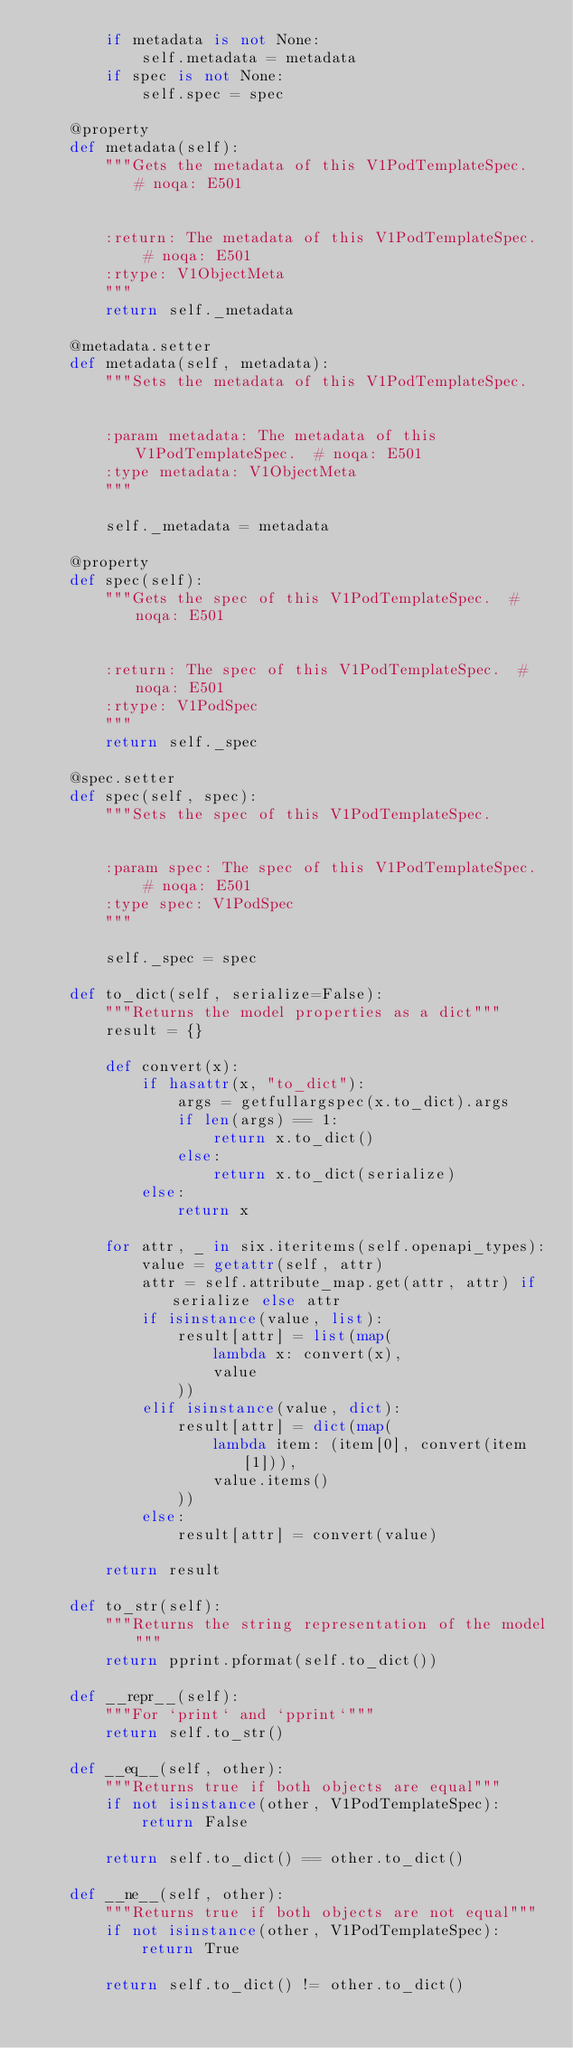<code> <loc_0><loc_0><loc_500><loc_500><_Python_>        if metadata is not None:
            self.metadata = metadata
        if spec is not None:
            self.spec = spec

    @property
    def metadata(self):
        """Gets the metadata of this V1PodTemplateSpec.  # noqa: E501


        :return: The metadata of this V1PodTemplateSpec.  # noqa: E501
        :rtype: V1ObjectMeta
        """
        return self._metadata

    @metadata.setter
    def metadata(self, metadata):
        """Sets the metadata of this V1PodTemplateSpec.


        :param metadata: The metadata of this V1PodTemplateSpec.  # noqa: E501
        :type metadata: V1ObjectMeta
        """

        self._metadata = metadata

    @property
    def spec(self):
        """Gets the spec of this V1PodTemplateSpec.  # noqa: E501


        :return: The spec of this V1PodTemplateSpec.  # noqa: E501
        :rtype: V1PodSpec
        """
        return self._spec

    @spec.setter
    def spec(self, spec):
        """Sets the spec of this V1PodTemplateSpec.


        :param spec: The spec of this V1PodTemplateSpec.  # noqa: E501
        :type spec: V1PodSpec
        """

        self._spec = spec

    def to_dict(self, serialize=False):
        """Returns the model properties as a dict"""
        result = {}

        def convert(x):
            if hasattr(x, "to_dict"):
                args = getfullargspec(x.to_dict).args
                if len(args) == 1:
                    return x.to_dict()
                else:
                    return x.to_dict(serialize)
            else:
                return x

        for attr, _ in six.iteritems(self.openapi_types):
            value = getattr(self, attr)
            attr = self.attribute_map.get(attr, attr) if serialize else attr
            if isinstance(value, list):
                result[attr] = list(map(
                    lambda x: convert(x),
                    value
                ))
            elif isinstance(value, dict):
                result[attr] = dict(map(
                    lambda item: (item[0], convert(item[1])),
                    value.items()
                ))
            else:
                result[attr] = convert(value)

        return result

    def to_str(self):
        """Returns the string representation of the model"""
        return pprint.pformat(self.to_dict())

    def __repr__(self):
        """For `print` and `pprint`"""
        return self.to_str()

    def __eq__(self, other):
        """Returns true if both objects are equal"""
        if not isinstance(other, V1PodTemplateSpec):
            return False

        return self.to_dict() == other.to_dict()

    def __ne__(self, other):
        """Returns true if both objects are not equal"""
        if not isinstance(other, V1PodTemplateSpec):
            return True

        return self.to_dict() != other.to_dict()
</code> 